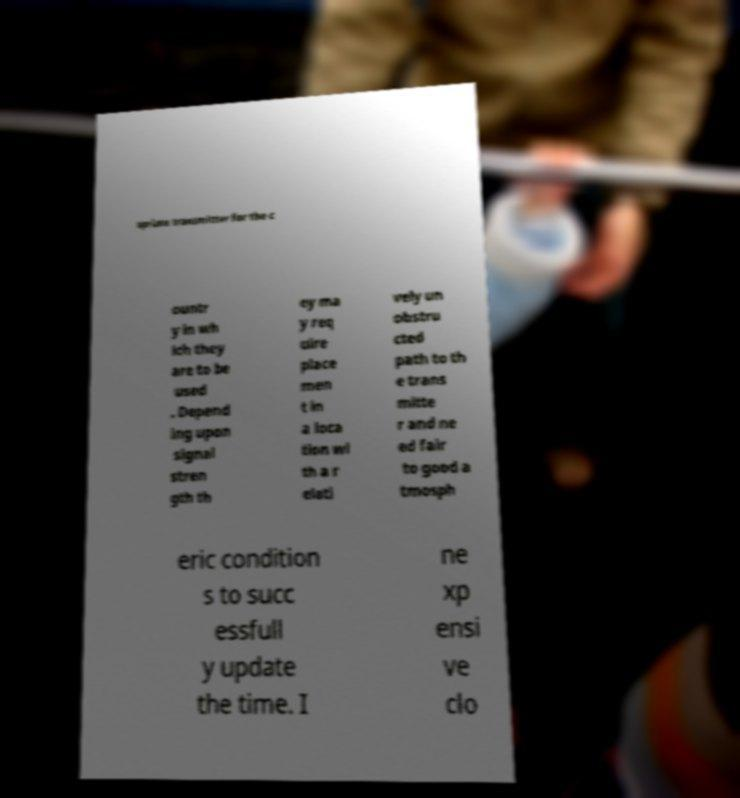What messages or text are displayed in this image? I need them in a readable, typed format. opriate transmitter for the c ountr y in wh ich they are to be used . Depend ing upon signal stren gth th ey ma y req uire place men t in a loca tion wi th a r elati vely un obstru cted path to th e trans mitte r and ne ed fair to good a tmosph eric condition s to succ essfull y update the time. I ne xp ensi ve clo 